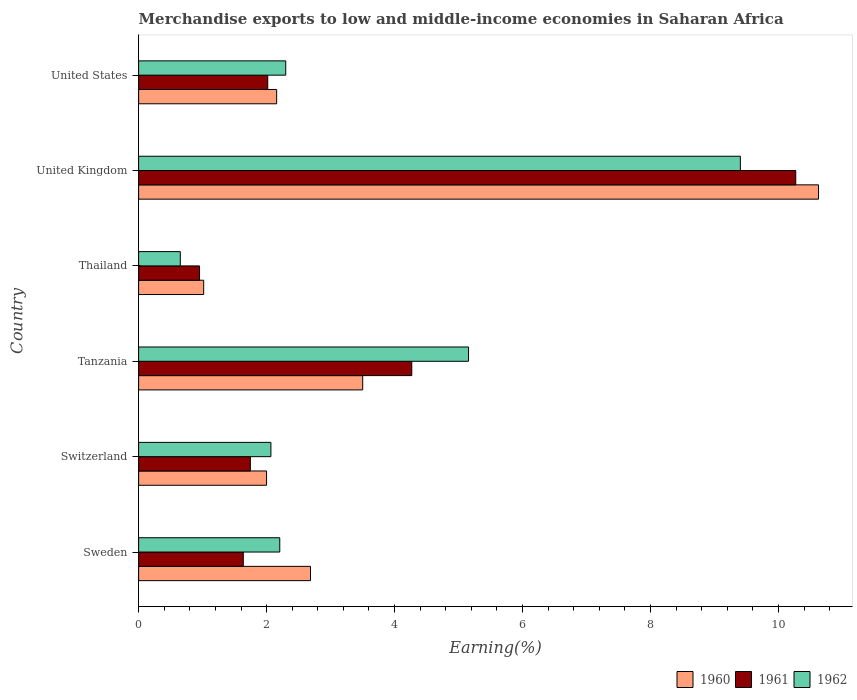How many different coloured bars are there?
Provide a succinct answer. 3. How many groups of bars are there?
Give a very brief answer. 6. Are the number of bars per tick equal to the number of legend labels?
Ensure brevity in your answer.  Yes. How many bars are there on the 5th tick from the bottom?
Make the answer very short. 3. In how many cases, is the number of bars for a given country not equal to the number of legend labels?
Your response must be concise. 0. What is the percentage of amount earned from merchandise exports in 1961 in Sweden?
Keep it short and to the point. 1.64. Across all countries, what is the maximum percentage of amount earned from merchandise exports in 1961?
Keep it short and to the point. 10.27. Across all countries, what is the minimum percentage of amount earned from merchandise exports in 1960?
Your answer should be compact. 1.02. In which country was the percentage of amount earned from merchandise exports in 1960 minimum?
Ensure brevity in your answer.  Thailand. What is the total percentage of amount earned from merchandise exports in 1961 in the graph?
Your answer should be compact. 20.89. What is the difference between the percentage of amount earned from merchandise exports in 1962 in Sweden and that in United States?
Provide a short and direct response. -0.09. What is the difference between the percentage of amount earned from merchandise exports in 1961 in Thailand and the percentage of amount earned from merchandise exports in 1960 in Switzerland?
Offer a terse response. -1.05. What is the average percentage of amount earned from merchandise exports in 1961 per country?
Offer a very short reply. 3.48. What is the difference between the percentage of amount earned from merchandise exports in 1962 and percentage of amount earned from merchandise exports in 1961 in Thailand?
Make the answer very short. -0.3. What is the ratio of the percentage of amount earned from merchandise exports in 1961 in Switzerland to that in Tanzania?
Provide a short and direct response. 0.41. Is the percentage of amount earned from merchandise exports in 1961 in Switzerland less than that in United States?
Keep it short and to the point. Yes. What is the difference between the highest and the second highest percentage of amount earned from merchandise exports in 1960?
Offer a very short reply. 7.12. What is the difference between the highest and the lowest percentage of amount earned from merchandise exports in 1961?
Your answer should be very brief. 9.32. In how many countries, is the percentage of amount earned from merchandise exports in 1961 greater than the average percentage of amount earned from merchandise exports in 1961 taken over all countries?
Your response must be concise. 2. Is the sum of the percentage of amount earned from merchandise exports in 1961 in Switzerland and United States greater than the maximum percentage of amount earned from merchandise exports in 1962 across all countries?
Offer a terse response. No. What does the 1st bar from the bottom in Sweden represents?
Give a very brief answer. 1960. Is it the case that in every country, the sum of the percentage of amount earned from merchandise exports in 1960 and percentage of amount earned from merchandise exports in 1961 is greater than the percentage of amount earned from merchandise exports in 1962?
Your answer should be compact. Yes. How many bars are there?
Keep it short and to the point. 18. How many countries are there in the graph?
Keep it short and to the point. 6. What is the difference between two consecutive major ticks on the X-axis?
Your answer should be compact. 2. Are the values on the major ticks of X-axis written in scientific E-notation?
Provide a short and direct response. No. Does the graph contain any zero values?
Keep it short and to the point. No. Does the graph contain grids?
Give a very brief answer. No. What is the title of the graph?
Your response must be concise. Merchandise exports to low and middle-income economies in Saharan Africa. What is the label or title of the X-axis?
Offer a very short reply. Earning(%). What is the label or title of the Y-axis?
Offer a terse response. Country. What is the Earning(%) in 1960 in Sweden?
Provide a short and direct response. 2.69. What is the Earning(%) of 1961 in Sweden?
Your answer should be very brief. 1.64. What is the Earning(%) of 1962 in Sweden?
Your answer should be compact. 2.21. What is the Earning(%) of 1960 in Switzerland?
Ensure brevity in your answer.  2. What is the Earning(%) in 1961 in Switzerland?
Your answer should be very brief. 1.75. What is the Earning(%) of 1962 in Switzerland?
Provide a short and direct response. 2.07. What is the Earning(%) of 1960 in Tanzania?
Provide a succinct answer. 3.5. What is the Earning(%) of 1961 in Tanzania?
Your response must be concise. 4.27. What is the Earning(%) in 1962 in Tanzania?
Provide a succinct answer. 5.16. What is the Earning(%) of 1960 in Thailand?
Offer a terse response. 1.02. What is the Earning(%) in 1961 in Thailand?
Your response must be concise. 0.95. What is the Earning(%) of 1962 in Thailand?
Make the answer very short. 0.65. What is the Earning(%) in 1960 in United Kingdom?
Offer a terse response. 10.63. What is the Earning(%) in 1961 in United Kingdom?
Keep it short and to the point. 10.27. What is the Earning(%) in 1962 in United Kingdom?
Give a very brief answer. 9.4. What is the Earning(%) of 1960 in United States?
Offer a very short reply. 2.16. What is the Earning(%) in 1961 in United States?
Give a very brief answer. 2.02. What is the Earning(%) in 1962 in United States?
Provide a succinct answer. 2.3. Across all countries, what is the maximum Earning(%) of 1960?
Your answer should be very brief. 10.63. Across all countries, what is the maximum Earning(%) in 1961?
Provide a short and direct response. 10.27. Across all countries, what is the maximum Earning(%) of 1962?
Offer a terse response. 9.4. Across all countries, what is the minimum Earning(%) in 1960?
Ensure brevity in your answer.  1.02. Across all countries, what is the minimum Earning(%) of 1961?
Make the answer very short. 0.95. Across all countries, what is the minimum Earning(%) in 1962?
Ensure brevity in your answer.  0.65. What is the total Earning(%) of 1960 in the graph?
Make the answer very short. 21.99. What is the total Earning(%) of 1961 in the graph?
Keep it short and to the point. 20.89. What is the total Earning(%) in 1962 in the graph?
Your response must be concise. 21.78. What is the difference between the Earning(%) in 1960 in Sweden and that in Switzerland?
Provide a short and direct response. 0.69. What is the difference between the Earning(%) in 1961 in Sweden and that in Switzerland?
Give a very brief answer. -0.11. What is the difference between the Earning(%) of 1962 in Sweden and that in Switzerland?
Provide a succinct answer. 0.14. What is the difference between the Earning(%) in 1960 in Sweden and that in Tanzania?
Your response must be concise. -0.82. What is the difference between the Earning(%) of 1961 in Sweden and that in Tanzania?
Offer a very short reply. -2.63. What is the difference between the Earning(%) in 1962 in Sweden and that in Tanzania?
Offer a terse response. -2.95. What is the difference between the Earning(%) of 1960 in Sweden and that in Thailand?
Your response must be concise. 1.67. What is the difference between the Earning(%) in 1961 in Sweden and that in Thailand?
Ensure brevity in your answer.  0.68. What is the difference between the Earning(%) in 1962 in Sweden and that in Thailand?
Your answer should be very brief. 1.55. What is the difference between the Earning(%) in 1960 in Sweden and that in United Kingdom?
Provide a succinct answer. -7.94. What is the difference between the Earning(%) of 1961 in Sweden and that in United Kingdom?
Ensure brevity in your answer.  -8.63. What is the difference between the Earning(%) of 1962 in Sweden and that in United Kingdom?
Keep it short and to the point. -7.2. What is the difference between the Earning(%) in 1960 in Sweden and that in United States?
Provide a succinct answer. 0.53. What is the difference between the Earning(%) in 1961 in Sweden and that in United States?
Make the answer very short. -0.38. What is the difference between the Earning(%) of 1962 in Sweden and that in United States?
Your response must be concise. -0.09. What is the difference between the Earning(%) of 1960 in Switzerland and that in Tanzania?
Provide a short and direct response. -1.5. What is the difference between the Earning(%) in 1961 in Switzerland and that in Tanzania?
Provide a short and direct response. -2.52. What is the difference between the Earning(%) in 1962 in Switzerland and that in Tanzania?
Offer a very short reply. -3.09. What is the difference between the Earning(%) of 1960 in Switzerland and that in Thailand?
Offer a terse response. 0.98. What is the difference between the Earning(%) in 1961 in Switzerland and that in Thailand?
Keep it short and to the point. 0.79. What is the difference between the Earning(%) in 1962 in Switzerland and that in Thailand?
Ensure brevity in your answer.  1.42. What is the difference between the Earning(%) of 1960 in Switzerland and that in United Kingdom?
Your response must be concise. -8.63. What is the difference between the Earning(%) of 1961 in Switzerland and that in United Kingdom?
Make the answer very short. -8.52. What is the difference between the Earning(%) in 1962 in Switzerland and that in United Kingdom?
Your answer should be compact. -7.34. What is the difference between the Earning(%) of 1960 in Switzerland and that in United States?
Your answer should be very brief. -0.16. What is the difference between the Earning(%) in 1961 in Switzerland and that in United States?
Keep it short and to the point. -0.27. What is the difference between the Earning(%) of 1962 in Switzerland and that in United States?
Ensure brevity in your answer.  -0.23. What is the difference between the Earning(%) in 1960 in Tanzania and that in Thailand?
Make the answer very short. 2.49. What is the difference between the Earning(%) of 1961 in Tanzania and that in Thailand?
Give a very brief answer. 3.32. What is the difference between the Earning(%) of 1962 in Tanzania and that in Thailand?
Your answer should be compact. 4.5. What is the difference between the Earning(%) in 1960 in Tanzania and that in United Kingdom?
Your answer should be compact. -7.12. What is the difference between the Earning(%) of 1961 in Tanzania and that in United Kingdom?
Provide a succinct answer. -6. What is the difference between the Earning(%) in 1962 in Tanzania and that in United Kingdom?
Provide a succinct answer. -4.25. What is the difference between the Earning(%) of 1960 in Tanzania and that in United States?
Ensure brevity in your answer.  1.34. What is the difference between the Earning(%) of 1961 in Tanzania and that in United States?
Provide a succinct answer. 2.25. What is the difference between the Earning(%) in 1962 in Tanzania and that in United States?
Make the answer very short. 2.86. What is the difference between the Earning(%) of 1960 in Thailand and that in United Kingdom?
Your answer should be very brief. -9.61. What is the difference between the Earning(%) in 1961 in Thailand and that in United Kingdom?
Keep it short and to the point. -9.32. What is the difference between the Earning(%) of 1962 in Thailand and that in United Kingdom?
Give a very brief answer. -8.75. What is the difference between the Earning(%) in 1960 in Thailand and that in United States?
Your answer should be very brief. -1.14. What is the difference between the Earning(%) of 1961 in Thailand and that in United States?
Provide a succinct answer. -1.07. What is the difference between the Earning(%) in 1962 in Thailand and that in United States?
Offer a very short reply. -1.65. What is the difference between the Earning(%) of 1960 in United Kingdom and that in United States?
Your answer should be very brief. 8.47. What is the difference between the Earning(%) of 1961 in United Kingdom and that in United States?
Keep it short and to the point. 8.25. What is the difference between the Earning(%) of 1962 in United Kingdom and that in United States?
Your answer should be compact. 7.11. What is the difference between the Earning(%) in 1960 in Sweden and the Earning(%) in 1961 in Switzerland?
Your response must be concise. 0.94. What is the difference between the Earning(%) of 1960 in Sweden and the Earning(%) of 1962 in Switzerland?
Your response must be concise. 0.62. What is the difference between the Earning(%) in 1961 in Sweden and the Earning(%) in 1962 in Switzerland?
Offer a very short reply. -0.43. What is the difference between the Earning(%) in 1960 in Sweden and the Earning(%) in 1961 in Tanzania?
Provide a succinct answer. -1.58. What is the difference between the Earning(%) in 1960 in Sweden and the Earning(%) in 1962 in Tanzania?
Provide a short and direct response. -2.47. What is the difference between the Earning(%) of 1961 in Sweden and the Earning(%) of 1962 in Tanzania?
Ensure brevity in your answer.  -3.52. What is the difference between the Earning(%) of 1960 in Sweden and the Earning(%) of 1961 in Thailand?
Offer a very short reply. 1.73. What is the difference between the Earning(%) in 1960 in Sweden and the Earning(%) in 1962 in Thailand?
Offer a terse response. 2.03. What is the difference between the Earning(%) in 1961 in Sweden and the Earning(%) in 1962 in Thailand?
Make the answer very short. 0.98. What is the difference between the Earning(%) of 1960 in Sweden and the Earning(%) of 1961 in United Kingdom?
Give a very brief answer. -7.58. What is the difference between the Earning(%) in 1960 in Sweden and the Earning(%) in 1962 in United Kingdom?
Your answer should be very brief. -6.72. What is the difference between the Earning(%) in 1961 in Sweden and the Earning(%) in 1962 in United Kingdom?
Make the answer very short. -7.77. What is the difference between the Earning(%) in 1960 in Sweden and the Earning(%) in 1961 in United States?
Offer a terse response. 0.67. What is the difference between the Earning(%) of 1960 in Sweden and the Earning(%) of 1962 in United States?
Your answer should be very brief. 0.39. What is the difference between the Earning(%) in 1961 in Sweden and the Earning(%) in 1962 in United States?
Keep it short and to the point. -0.66. What is the difference between the Earning(%) in 1960 in Switzerland and the Earning(%) in 1961 in Tanzania?
Your answer should be very brief. -2.27. What is the difference between the Earning(%) of 1960 in Switzerland and the Earning(%) of 1962 in Tanzania?
Give a very brief answer. -3.16. What is the difference between the Earning(%) in 1961 in Switzerland and the Earning(%) in 1962 in Tanzania?
Offer a terse response. -3.41. What is the difference between the Earning(%) in 1960 in Switzerland and the Earning(%) in 1961 in Thailand?
Your answer should be compact. 1.05. What is the difference between the Earning(%) in 1960 in Switzerland and the Earning(%) in 1962 in Thailand?
Offer a terse response. 1.35. What is the difference between the Earning(%) of 1961 in Switzerland and the Earning(%) of 1962 in Thailand?
Offer a very short reply. 1.1. What is the difference between the Earning(%) of 1960 in Switzerland and the Earning(%) of 1961 in United Kingdom?
Offer a very short reply. -8.27. What is the difference between the Earning(%) of 1960 in Switzerland and the Earning(%) of 1962 in United Kingdom?
Offer a terse response. -7.4. What is the difference between the Earning(%) of 1961 in Switzerland and the Earning(%) of 1962 in United Kingdom?
Your answer should be compact. -7.66. What is the difference between the Earning(%) in 1960 in Switzerland and the Earning(%) in 1961 in United States?
Your answer should be compact. -0.02. What is the difference between the Earning(%) in 1960 in Switzerland and the Earning(%) in 1962 in United States?
Your answer should be very brief. -0.3. What is the difference between the Earning(%) in 1961 in Switzerland and the Earning(%) in 1962 in United States?
Provide a short and direct response. -0.55. What is the difference between the Earning(%) of 1960 in Tanzania and the Earning(%) of 1961 in Thailand?
Make the answer very short. 2.55. What is the difference between the Earning(%) of 1960 in Tanzania and the Earning(%) of 1962 in Thailand?
Provide a short and direct response. 2.85. What is the difference between the Earning(%) in 1961 in Tanzania and the Earning(%) in 1962 in Thailand?
Your answer should be very brief. 3.62. What is the difference between the Earning(%) of 1960 in Tanzania and the Earning(%) of 1961 in United Kingdom?
Your answer should be compact. -6.77. What is the difference between the Earning(%) in 1960 in Tanzania and the Earning(%) in 1962 in United Kingdom?
Keep it short and to the point. -5.9. What is the difference between the Earning(%) of 1961 in Tanzania and the Earning(%) of 1962 in United Kingdom?
Offer a very short reply. -5.14. What is the difference between the Earning(%) in 1960 in Tanzania and the Earning(%) in 1961 in United States?
Provide a short and direct response. 1.48. What is the difference between the Earning(%) of 1960 in Tanzania and the Earning(%) of 1962 in United States?
Your answer should be compact. 1.2. What is the difference between the Earning(%) in 1961 in Tanzania and the Earning(%) in 1962 in United States?
Give a very brief answer. 1.97. What is the difference between the Earning(%) in 1960 in Thailand and the Earning(%) in 1961 in United Kingdom?
Keep it short and to the point. -9.25. What is the difference between the Earning(%) in 1960 in Thailand and the Earning(%) in 1962 in United Kingdom?
Your answer should be compact. -8.39. What is the difference between the Earning(%) of 1961 in Thailand and the Earning(%) of 1962 in United Kingdom?
Offer a terse response. -8.45. What is the difference between the Earning(%) in 1960 in Thailand and the Earning(%) in 1961 in United States?
Keep it short and to the point. -1. What is the difference between the Earning(%) in 1960 in Thailand and the Earning(%) in 1962 in United States?
Give a very brief answer. -1.28. What is the difference between the Earning(%) of 1961 in Thailand and the Earning(%) of 1962 in United States?
Ensure brevity in your answer.  -1.35. What is the difference between the Earning(%) in 1960 in United Kingdom and the Earning(%) in 1961 in United States?
Provide a succinct answer. 8.61. What is the difference between the Earning(%) of 1960 in United Kingdom and the Earning(%) of 1962 in United States?
Provide a short and direct response. 8.33. What is the difference between the Earning(%) of 1961 in United Kingdom and the Earning(%) of 1962 in United States?
Make the answer very short. 7.97. What is the average Earning(%) in 1960 per country?
Your answer should be very brief. 3.66. What is the average Earning(%) of 1961 per country?
Your answer should be very brief. 3.48. What is the average Earning(%) of 1962 per country?
Offer a terse response. 3.63. What is the difference between the Earning(%) in 1960 and Earning(%) in 1961 in Sweden?
Offer a very short reply. 1.05. What is the difference between the Earning(%) of 1960 and Earning(%) of 1962 in Sweden?
Provide a succinct answer. 0.48. What is the difference between the Earning(%) of 1961 and Earning(%) of 1962 in Sweden?
Provide a succinct answer. -0.57. What is the difference between the Earning(%) in 1960 and Earning(%) in 1961 in Switzerland?
Make the answer very short. 0.25. What is the difference between the Earning(%) of 1960 and Earning(%) of 1962 in Switzerland?
Ensure brevity in your answer.  -0.07. What is the difference between the Earning(%) of 1961 and Earning(%) of 1962 in Switzerland?
Provide a succinct answer. -0.32. What is the difference between the Earning(%) of 1960 and Earning(%) of 1961 in Tanzania?
Provide a short and direct response. -0.77. What is the difference between the Earning(%) in 1960 and Earning(%) in 1962 in Tanzania?
Provide a short and direct response. -1.65. What is the difference between the Earning(%) of 1961 and Earning(%) of 1962 in Tanzania?
Offer a terse response. -0.89. What is the difference between the Earning(%) of 1960 and Earning(%) of 1961 in Thailand?
Give a very brief answer. 0.06. What is the difference between the Earning(%) in 1960 and Earning(%) in 1962 in Thailand?
Your answer should be very brief. 0.37. What is the difference between the Earning(%) of 1961 and Earning(%) of 1962 in Thailand?
Your response must be concise. 0.3. What is the difference between the Earning(%) of 1960 and Earning(%) of 1961 in United Kingdom?
Offer a very short reply. 0.36. What is the difference between the Earning(%) in 1960 and Earning(%) in 1962 in United Kingdom?
Provide a succinct answer. 1.22. What is the difference between the Earning(%) in 1961 and Earning(%) in 1962 in United Kingdom?
Ensure brevity in your answer.  0.87. What is the difference between the Earning(%) in 1960 and Earning(%) in 1961 in United States?
Provide a short and direct response. 0.14. What is the difference between the Earning(%) in 1960 and Earning(%) in 1962 in United States?
Provide a succinct answer. -0.14. What is the difference between the Earning(%) of 1961 and Earning(%) of 1962 in United States?
Your answer should be compact. -0.28. What is the ratio of the Earning(%) of 1960 in Sweden to that in Switzerland?
Provide a short and direct response. 1.34. What is the ratio of the Earning(%) in 1961 in Sweden to that in Switzerland?
Offer a terse response. 0.94. What is the ratio of the Earning(%) in 1962 in Sweden to that in Switzerland?
Keep it short and to the point. 1.07. What is the ratio of the Earning(%) of 1960 in Sweden to that in Tanzania?
Your answer should be very brief. 0.77. What is the ratio of the Earning(%) of 1961 in Sweden to that in Tanzania?
Your answer should be very brief. 0.38. What is the ratio of the Earning(%) in 1962 in Sweden to that in Tanzania?
Ensure brevity in your answer.  0.43. What is the ratio of the Earning(%) in 1960 in Sweden to that in Thailand?
Your response must be concise. 2.64. What is the ratio of the Earning(%) in 1961 in Sweden to that in Thailand?
Ensure brevity in your answer.  1.72. What is the ratio of the Earning(%) in 1962 in Sweden to that in Thailand?
Ensure brevity in your answer.  3.39. What is the ratio of the Earning(%) of 1960 in Sweden to that in United Kingdom?
Keep it short and to the point. 0.25. What is the ratio of the Earning(%) in 1961 in Sweden to that in United Kingdom?
Give a very brief answer. 0.16. What is the ratio of the Earning(%) of 1962 in Sweden to that in United Kingdom?
Give a very brief answer. 0.23. What is the ratio of the Earning(%) of 1960 in Sweden to that in United States?
Ensure brevity in your answer.  1.25. What is the ratio of the Earning(%) in 1961 in Sweden to that in United States?
Offer a very short reply. 0.81. What is the ratio of the Earning(%) of 1962 in Sweden to that in United States?
Your answer should be compact. 0.96. What is the ratio of the Earning(%) of 1960 in Switzerland to that in Tanzania?
Your answer should be compact. 0.57. What is the ratio of the Earning(%) in 1961 in Switzerland to that in Tanzania?
Offer a terse response. 0.41. What is the ratio of the Earning(%) of 1962 in Switzerland to that in Tanzania?
Provide a succinct answer. 0.4. What is the ratio of the Earning(%) in 1960 in Switzerland to that in Thailand?
Your response must be concise. 1.97. What is the ratio of the Earning(%) of 1961 in Switzerland to that in Thailand?
Offer a very short reply. 1.83. What is the ratio of the Earning(%) of 1962 in Switzerland to that in Thailand?
Make the answer very short. 3.17. What is the ratio of the Earning(%) of 1960 in Switzerland to that in United Kingdom?
Ensure brevity in your answer.  0.19. What is the ratio of the Earning(%) of 1961 in Switzerland to that in United Kingdom?
Provide a succinct answer. 0.17. What is the ratio of the Earning(%) of 1962 in Switzerland to that in United Kingdom?
Your answer should be very brief. 0.22. What is the ratio of the Earning(%) in 1960 in Switzerland to that in United States?
Ensure brevity in your answer.  0.93. What is the ratio of the Earning(%) of 1961 in Switzerland to that in United States?
Your answer should be very brief. 0.87. What is the ratio of the Earning(%) in 1962 in Switzerland to that in United States?
Your response must be concise. 0.9. What is the ratio of the Earning(%) in 1960 in Tanzania to that in Thailand?
Make the answer very short. 3.44. What is the ratio of the Earning(%) in 1961 in Tanzania to that in Thailand?
Your response must be concise. 4.48. What is the ratio of the Earning(%) in 1962 in Tanzania to that in Thailand?
Give a very brief answer. 7.92. What is the ratio of the Earning(%) of 1960 in Tanzania to that in United Kingdom?
Ensure brevity in your answer.  0.33. What is the ratio of the Earning(%) in 1961 in Tanzania to that in United Kingdom?
Your response must be concise. 0.42. What is the ratio of the Earning(%) in 1962 in Tanzania to that in United Kingdom?
Make the answer very short. 0.55. What is the ratio of the Earning(%) of 1960 in Tanzania to that in United States?
Provide a short and direct response. 1.62. What is the ratio of the Earning(%) of 1961 in Tanzania to that in United States?
Make the answer very short. 2.12. What is the ratio of the Earning(%) of 1962 in Tanzania to that in United States?
Your answer should be very brief. 2.24. What is the ratio of the Earning(%) in 1960 in Thailand to that in United Kingdom?
Give a very brief answer. 0.1. What is the ratio of the Earning(%) in 1961 in Thailand to that in United Kingdom?
Provide a succinct answer. 0.09. What is the ratio of the Earning(%) in 1962 in Thailand to that in United Kingdom?
Your response must be concise. 0.07. What is the ratio of the Earning(%) of 1960 in Thailand to that in United States?
Your answer should be compact. 0.47. What is the ratio of the Earning(%) of 1961 in Thailand to that in United States?
Provide a short and direct response. 0.47. What is the ratio of the Earning(%) in 1962 in Thailand to that in United States?
Make the answer very short. 0.28. What is the ratio of the Earning(%) of 1960 in United Kingdom to that in United States?
Keep it short and to the point. 4.93. What is the ratio of the Earning(%) in 1961 in United Kingdom to that in United States?
Your answer should be very brief. 5.09. What is the ratio of the Earning(%) of 1962 in United Kingdom to that in United States?
Your answer should be very brief. 4.09. What is the difference between the highest and the second highest Earning(%) of 1960?
Ensure brevity in your answer.  7.12. What is the difference between the highest and the second highest Earning(%) of 1961?
Offer a very short reply. 6. What is the difference between the highest and the second highest Earning(%) in 1962?
Make the answer very short. 4.25. What is the difference between the highest and the lowest Earning(%) in 1960?
Ensure brevity in your answer.  9.61. What is the difference between the highest and the lowest Earning(%) of 1961?
Your answer should be very brief. 9.32. What is the difference between the highest and the lowest Earning(%) in 1962?
Your answer should be very brief. 8.75. 